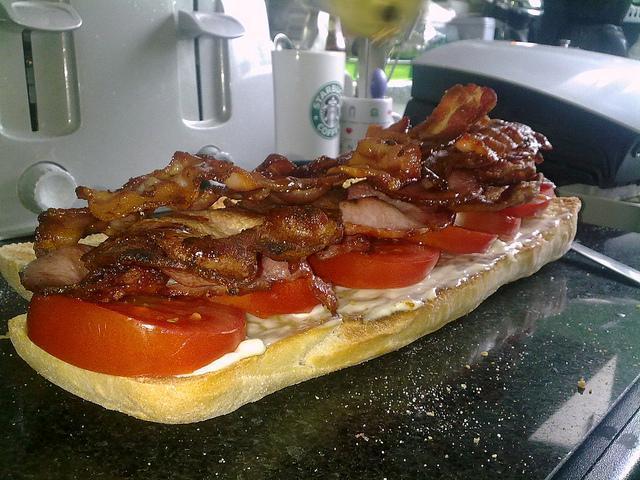How many giraffes are there?
Give a very brief answer. 0. 